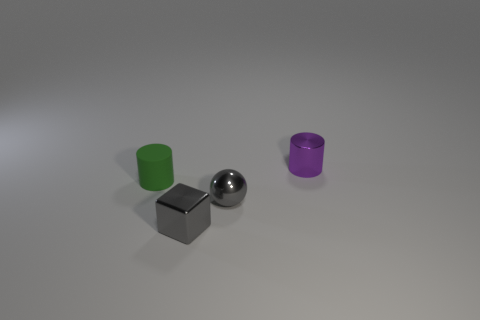How many balls have the same size as the purple shiny cylinder?
Give a very brief answer. 1. There is a small metal thing that is behind the green rubber object; what color is it?
Keep it short and to the point. Purple. What number of other objects are the same size as the green thing?
Your answer should be very brief. 3. How big is the metal thing that is both on the right side of the gray cube and on the left side of the small metallic cylinder?
Your answer should be compact. Small. There is a ball; is its color the same as the cylinder to the right of the tiny gray ball?
Keep it short and to the point. No. Is there a tiny brown matte thing that has the same shape as the tiny green thing?
Give a very brief answer. No. What number of objects are either large red spheres or small metallic blocks in front of the small purple metallic cylinder?
Offer a very short reply. 1. How many other things are made of the same material as the green thing?
Ensure brevity in your answer.  0. What number of things are tiny metallic balls or big cyan balls?
Make the answer very short. 1. Is the number of small green rubber cylinders that are right of the tiny purple cylinder greater than the number of small purple objects to the left of the metallic ball?
Your answer should be compact. No. 